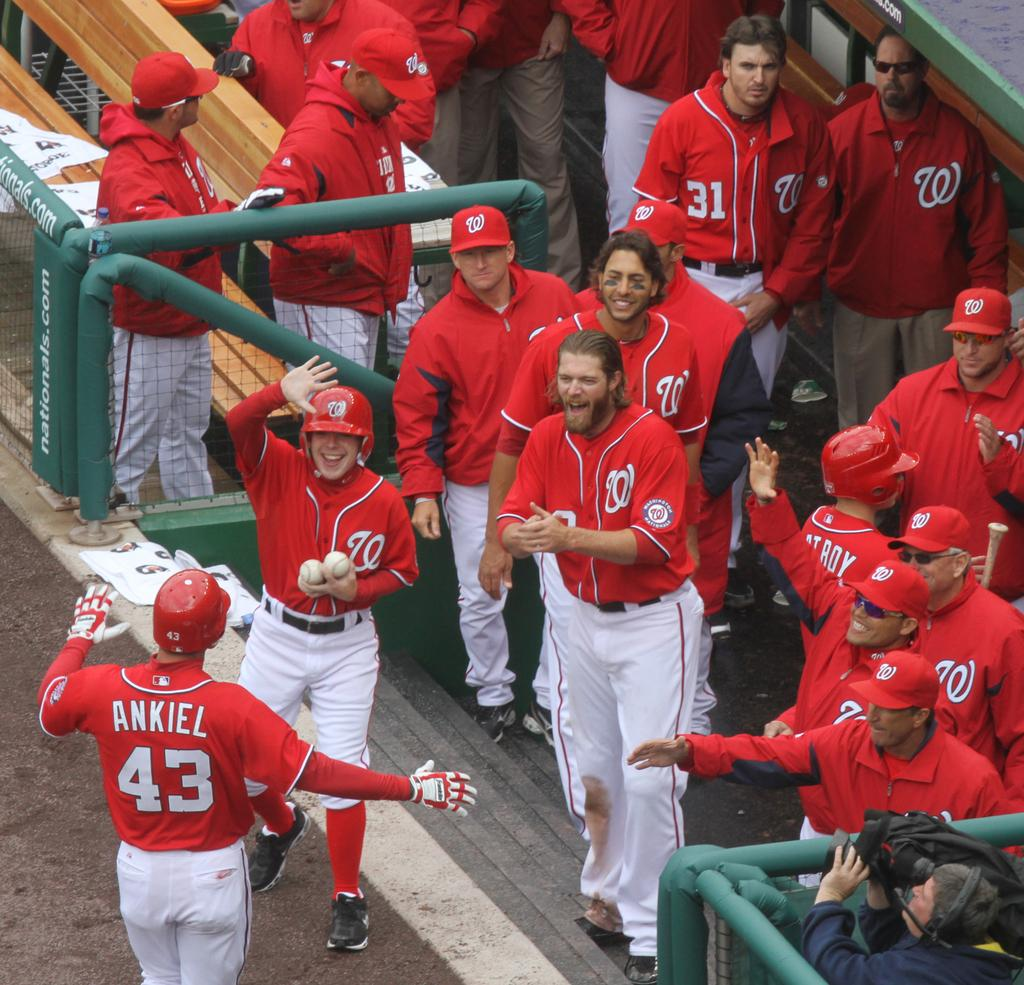<image>
Offer a succinct explanation of the picture presented. The player named Ankiel is warmly greeted by his teammates. 